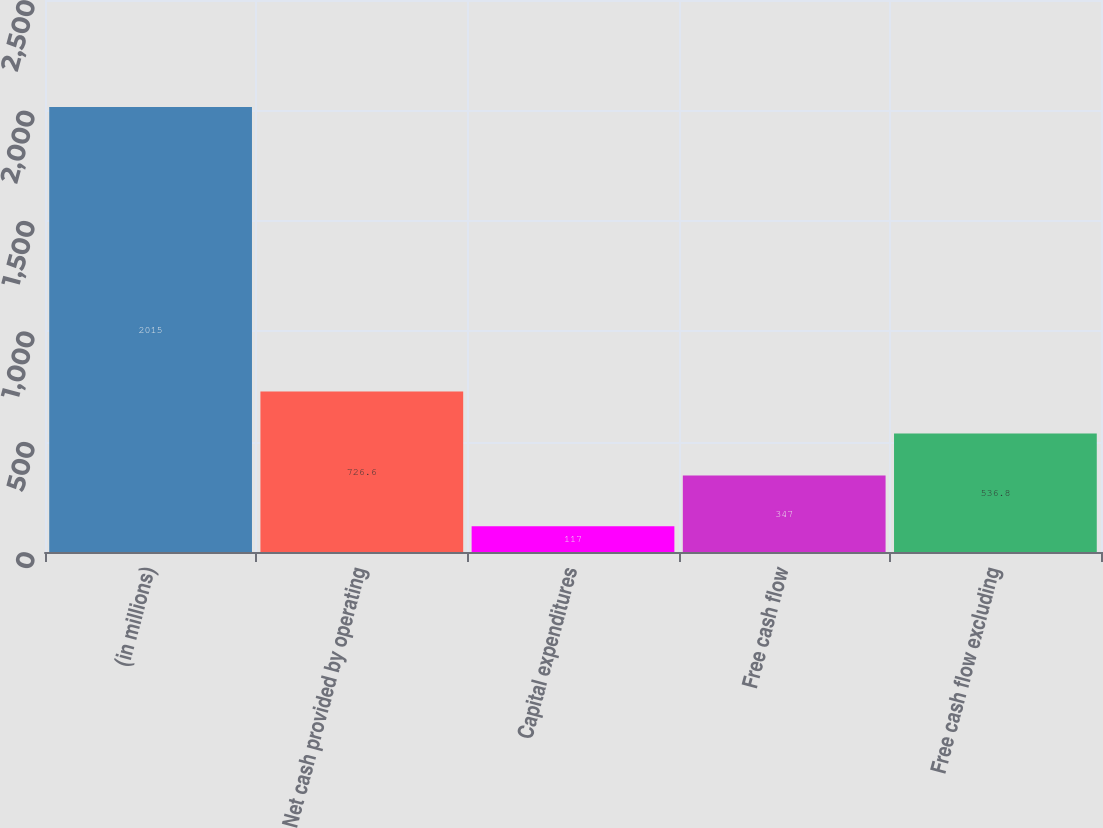<chart> <loc_0><loc_0><loc_500><loc_500><bar_chart><fcel>(in millions)<fcel>Net cash provided by operating<fcel>Capital expenditures<fcel>Free cash flow<fcel>Free cash flow excluding<nl><fcel>2015<fcel>726.6<fcel>117<fcel>347<fcel>536.8<nl></chart> 